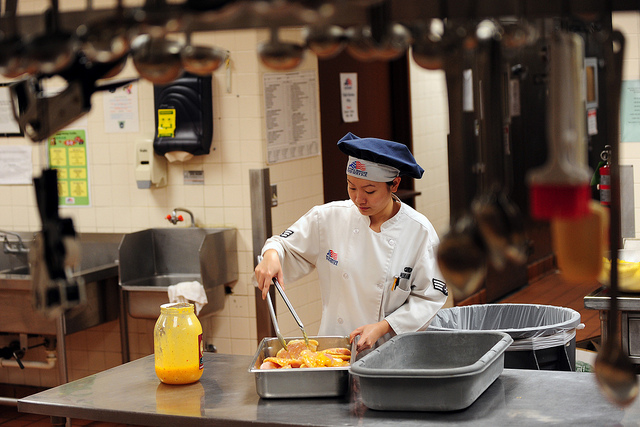How would the kitchen dynamics change if it were in a bustling restaurant during peak hours? In a bustling restaurant during peak hours, the kitchen dynamics would be far more hectic and fast-paced. Multiple chefs would be working in tandem, each fulfilling specific roles like prepping, cooking, plating, and expediting orders. Communication would be crucial, with constant verbal exchanges to coordinate the preparation of numerous dishes simultaneously. The atmosphere would be filled with the sounds of sizzling pans, clanging utensils, and the urgent calls of chefs. Cleaning would need to be swift but thorough, ensuring that workspace remains manageable and sanitary amid the flurry of activity. Every surface would need to be cleared and cleaned quickly to make room for continuous cooking, emphasizing the importance of teamwork and efficiency in maintaining both cleanliness and productivity.  What precautions can be taken to prevent cross-contamination in the kitchen? To prevent cross-contamination in the kitchen, several precautions can be implemented:

1. Use separate cutting boards and utensils for raw and cooked foods.
2. Frequently wash hands, especially after handling raw ingredients.
3. Clean and sanitize kitchen surfaces regularly.
4. Store raw meats and their juices away from other foods, particularly those that won’t be cooked before consumption.
5. Use color-coded kitchen tools to distinguish between different types of foods and their preparation stages.
6. Ensure that cleaning cloths and sponges are sanitized and replaced regularly to avoid bacterial buildup.
By following these protocols, the risk of spreading harmful bacteria and contaminating food can be significantly reduced. 